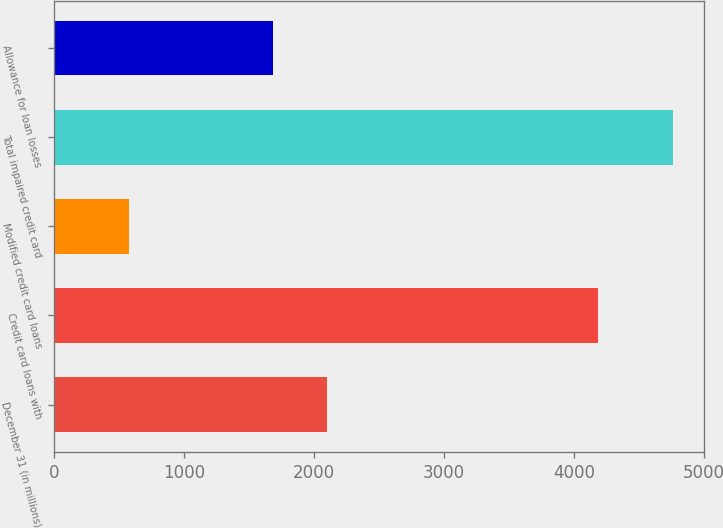Convert chart. <chart><loc_0><loc_0><loc_500><loc_500><bar_chart><fcel>December 31 (in millions)<fcel>Credit card loans with<fcel>Modified credit card loans<fcel>Total impaired credit card<fcel>Allowance for loan losses<nl><fcel>2099.9<fcel>4189<fcel>573<fcel>4762<fcel>1681<nl></chart> 